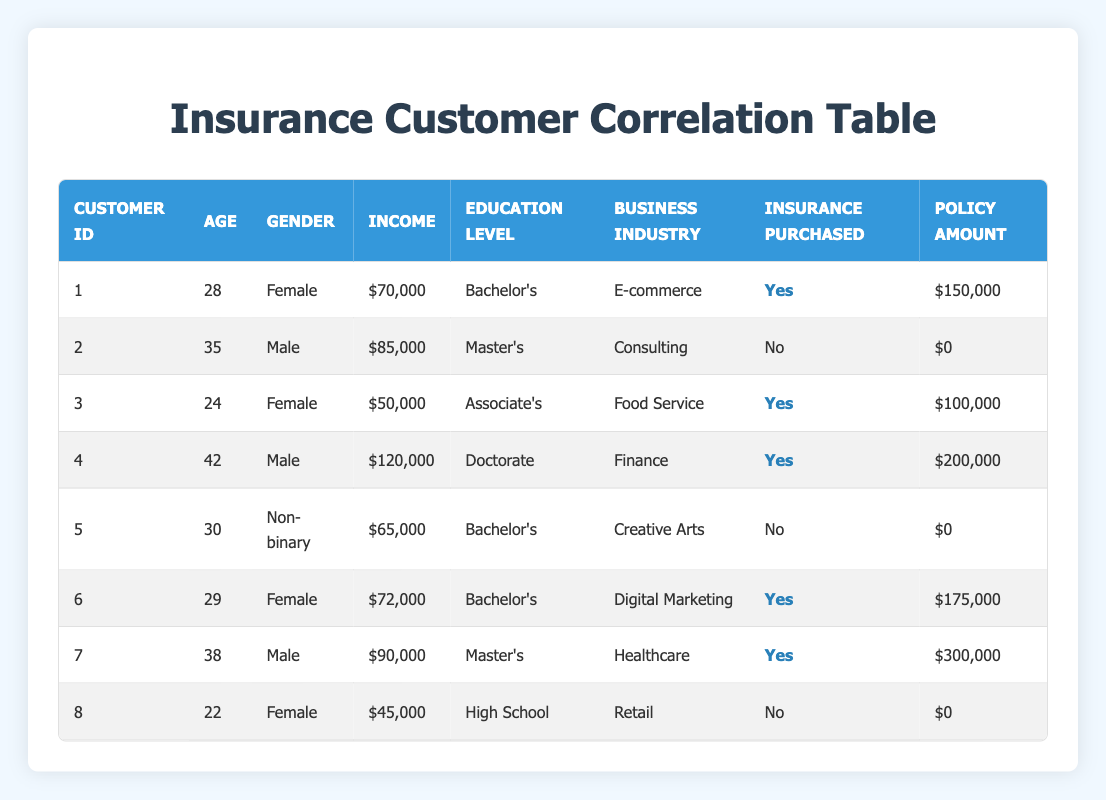What is the average income of customers who purchased insurance? The customers who purchased insurance are customer ID 1, 3, 4, 6, and 7. Their incomes are $70,000, $50,000, $120,000, $72,000, and $90,000 respectively. To find the average, we sum these values: $70,000 + $50,000 + $120,000 + $72,000 + $90,000 = $402,000. There are 5 customers who purchased insurance, so the average income is $402,000 / 5 = $80,400.
Answer: $80,400 How many customers in the table are aged 30 or older and purchased insurance? The customers aged 30 or older are customer ID 2 (age 35), customer ID 4 (age 42), and customer ID 7 (age 38). Among these, customer ID 4 and customer ID 7 have purchased insurance. Hence, there are 2 such customers.
Answer: 2 Is there any customer who purchased insurance and works in the E-commerce industry? Looking through the table, customer ID 1 works in the E-commerce industry and has purchased insurance. Thus, the answer is yes.
Answer: Yes What is the total policy amount purchased by all customers? The policy amounts for customers are $150,000 (ID 1), $0 (ID 2), $100,000 (ID 3), $200,000 (ID 4), $0 (ID 5), $175,000 (ID 6), $300,000 (ID 7), and $0 (ID 8). Summing these amounts gives: $150,000 + $0 + $100,000 + $200,000 + $0 + $175,000 + $300,000 + $0 = $925,000. Hence, the total policy amount is $925,000.
Answer: $925,000 Which gender has more customers that purchased insurance? Reviewing the table, the customers who purchased insurance are customer ID 1 (Female), customer ID 3 (Female), customer ID 4 (Male), customer ID 6 (Female), and customer ID 7 (Male). There are 3 Females and 2 Males who purchased insurance. Therefore, Females have more customers that purchased insurance.
Answer: Female 